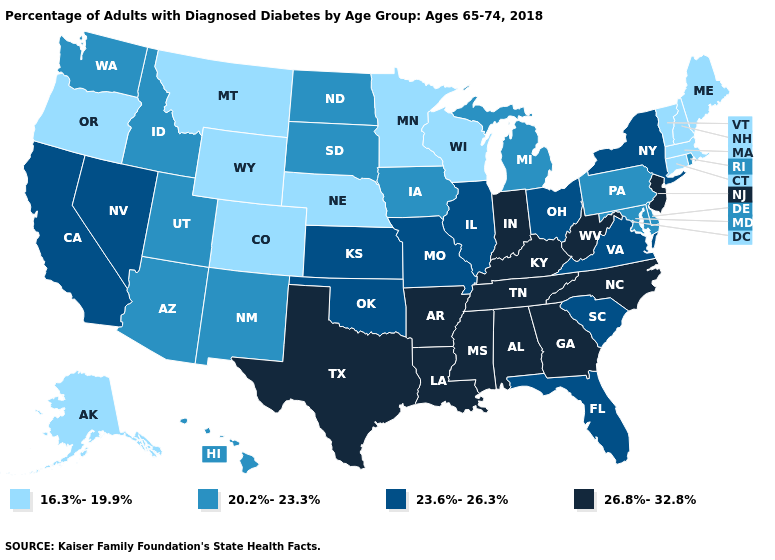Name the states that have a value in the range 26.8%-32.8%?
Concise answer only. Alabama, Arkansas, Georgia, Indiana, Kentucky, Louisiana, Mississippi, New Jersey, North Carolina, Tennessee, Texas, West Virginia. What is the value of Missouri?
Answer briefly. 23.6%-26.3%. What is the highest value in the USA?
Quick response, please. 26.8%-32.8%. Name the states that have a value in the range 16.3%-19.9%?
Keep it brief. Alaska, Colorado, Connecticut, Maine, Massachusetts, Minnesota, Montana, Nebraska, New Hampshire, Oregon, Vermont, Wisconsin, Wyoming. Does North Carolina have the highest value in the USA?
Write a very short answer. Yes. Does Alaska have the lowest value in the West?
Short answer required. Yes. Among the states that border Kentucky , which have the highest value?
Quick response, please. Indiana, Tennessee, West Virginia. Which states have the lowest value in the USA?
Keep it brief. Alaska, Colorado, Connecticut, Maine, Massachusetts, Minnesota, Montana, Nebraska, New Hampshire, Oregon, Vermont, Wisconsin, Wyoming. Does Minnesota have the lowest value in the MidWest?
Answer briefly. Yes. Is the legend a continuous bar?
Write a very short answer. No. Among the states that border New Hampshire , which have the lowest value?
Short answer required. Maine, Massachusetts, Vermont. What is the value of Idaho?
Short answer required. 20.2%-23.3%. What is the value of Nebraska?
Be succinct. 16.3%-19.9%. What is the value of North Carolina?
Answer briefly. 26.8%-32.8%. What is the highest value in states that border California?
Quick response, please. 23.6%-26.3%. 